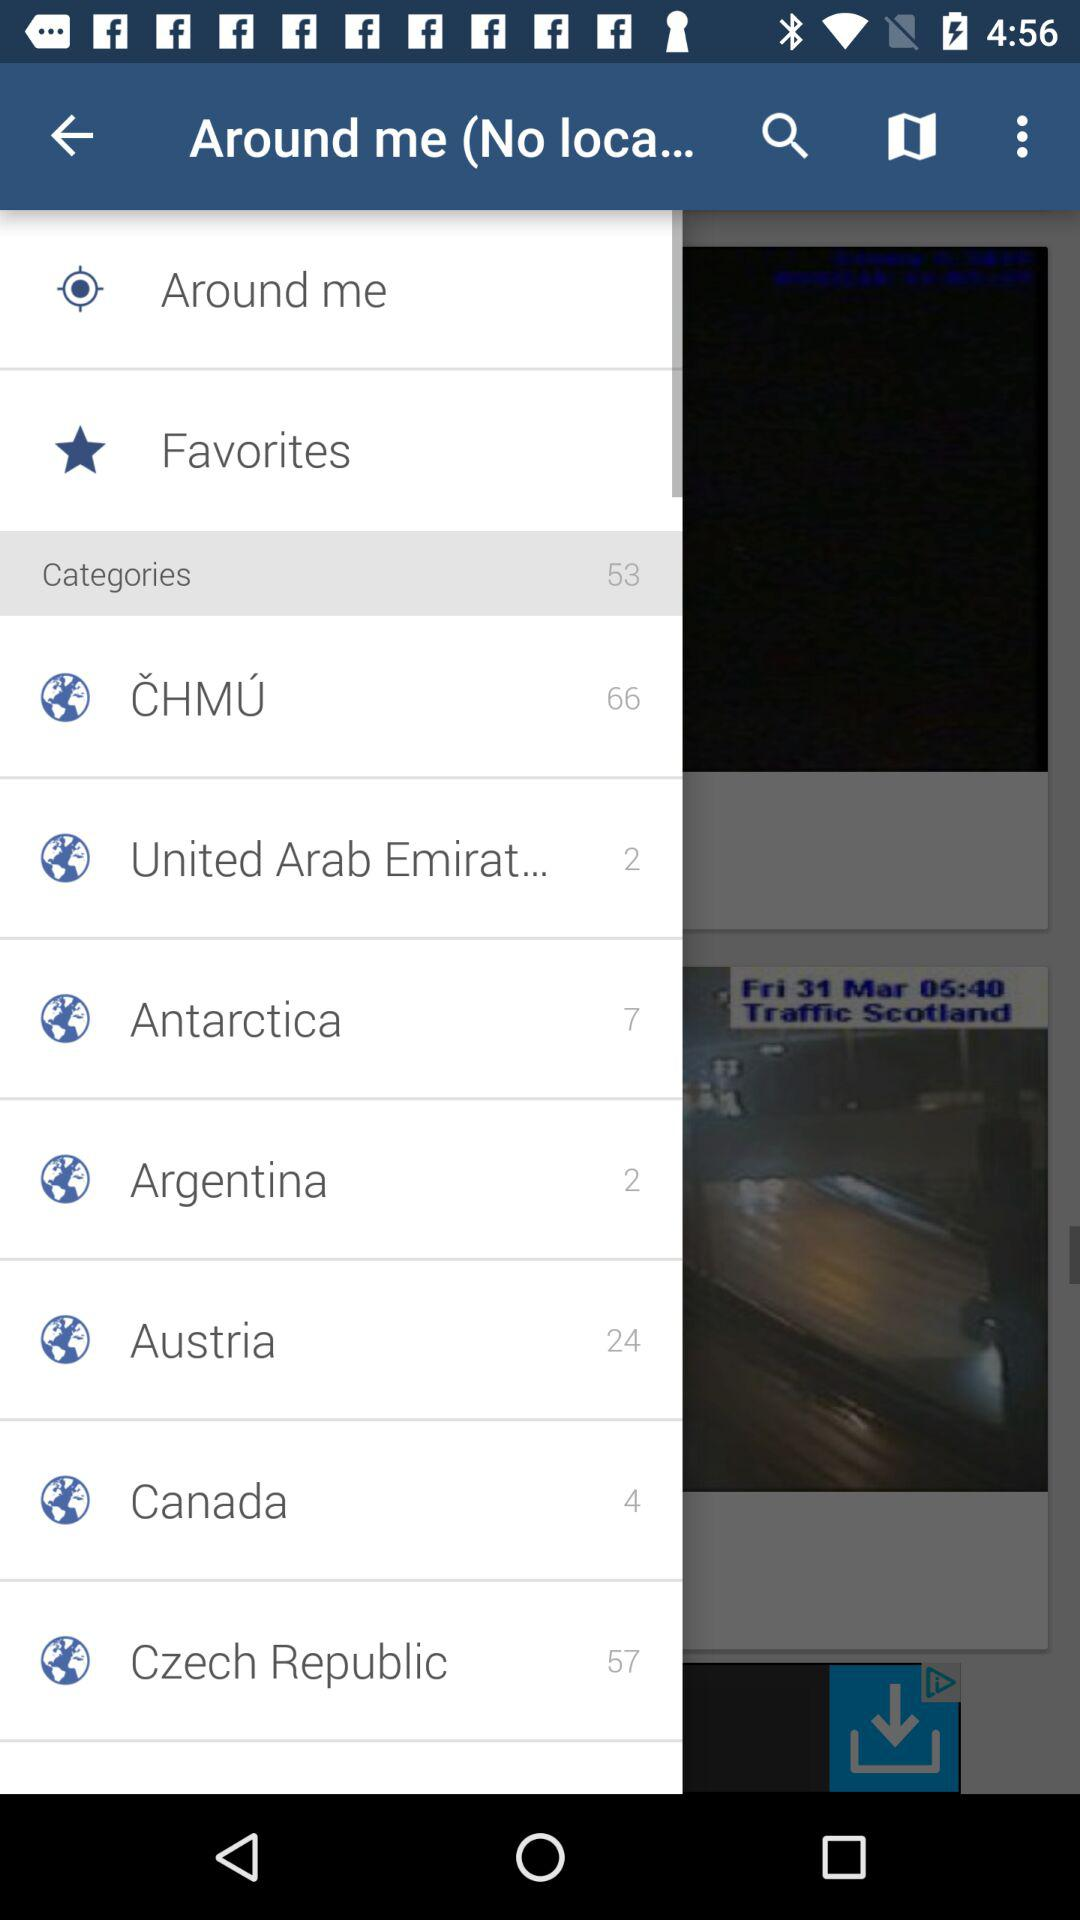How many categories are in Austria? There are 24 categories. 